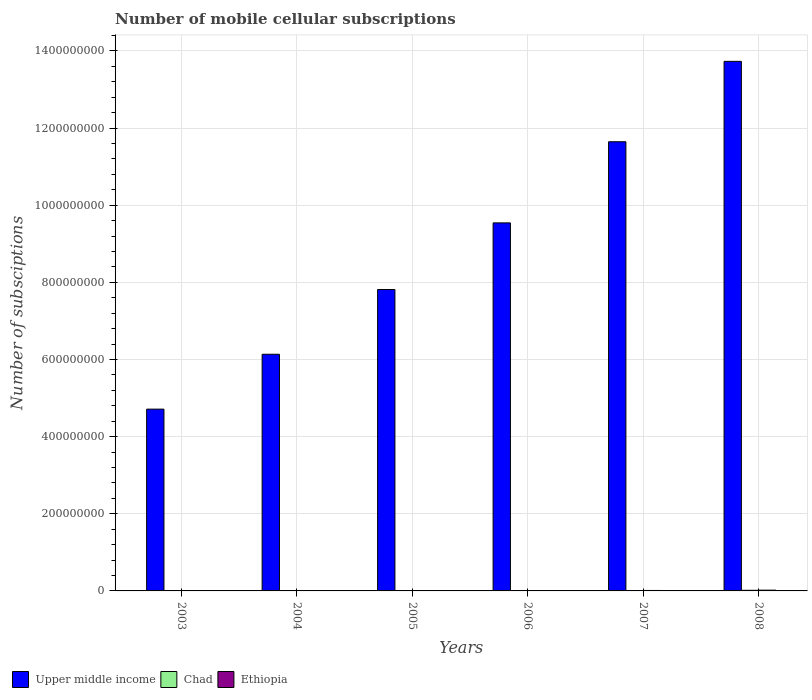How many bars are there on the 6th tick from the left?
Your answer should be very brief. 3. What is the label of the 6th group of bars from the left?
Offer a very short reply. 2008. What is the number of mobile cellular subscriptions in Ethiopia in 2008?
Offer a very short reply. 1.95e+06. Across all years, what is the maximum number of mobile cellular subscriptions in Ethiopia?
Make the answer very short. 1.95e+06. Across all years, what is the minimum number of mobile cellular subscriptions in Ethiopia?
Give a very brief answer. 5.13e+04. In which year was the number of mobile cellular subscriptions in Ethiopia maximum?
Offer a terse response. 2008. What is the total number of mobile cellular subscriptions in Ethiopia in the graph?
Give a very brief answer. 4.65e+06. What is the difference between the number of mobile cellular subscriptions in Upper middle income in 2003 and that in 2008?
Your answer should be compact. -9.02e+08. What is the difference between the number of mobile cellular subscriptions in Ethiopia in 2003 and the number of mobile cellular subscriptions in Upper middle income in 2006?
Your response must be concise. -9.54e+08. What is the average number of mobile cellular subscriptions in Ethiopia per year?
Give a very brief answer. 7.75e+05. In the year 2003, what is the difference between the number of mobile cellular subscriptions in Ethiopia and number of mobile cellular subscriptions in Chad?
Offer a very short reply. -1.37e+04. What is the ratio of the number of mobile cellular subscriptions in Ethiopia in 2006 to that in 2007?
Offer a very short reply. 0.72. What is the difference between the highest and the second highest number of mobile cellular subscriptions in Chad?
Provide a short and direct response. 6.82e+05. What is the difference between the highest and the lowest number of mobile cellular subscriptions in Ethiopia?
Ensure brevity in your answer.  1.90e+06. Is the sum of the number of mobile cellular subscriptions in Upper middle income in 2004 and 2005 greater than the maximum number of mobile cellular subscriptions in Chad across all years?
Offer a terse response. Yes. What does the 3rd bar from the left in 2006 represents?
Your answer should be very brief. Ethiopia. What does the 1st bar from the right in 2004 represents?
Keep it short and to the point. Ethiopia. Are all the bars in the graph horizontal?
Provide a short and direct response. No. What is the difference between two consecutive major ticks on the Y-axis?
Ensure brevity in your answer.  2.00e+08. How many legend labels are there?
Provide a short and direct response. 3. What is the title of the graph?
Provide a succinct answer. Number of mobile cellular subscriptions. Does "France" appear as one of the legend labels in the graph?
Ensure brevity in your answer.  No. What is the label or title of the Y-axis?
Your answer should be very brief. Number of subsciptions. What is the Number of subsciptions of Upper middle income in 2003?
Your answer should be very brief. 4.71e+08. What is the Number of subsciptions of Chad in 2003?
Offer a very short reply. 6.50e+04. What is the Number of subsciptions in Ethiopia in 2003?
Your response must be concise. 5.13e+04. What is the Number of subsciptions in Upper middle income in 2004?
Provide a succinct answer. 6.14e+08. What is the Number of subsciptions in Chad in 2004?
Make the answer very short. 1.23e+05. What is the Number of subsciptions in Ethiopia in 2004?
Provide a short and direct response. 1.56e+05. What is the Number of subsciptions of Upper middle income in 2005?
Offer a very short reply. 7.81e+08. What is the Number of subsciptions of Ethiopia in 2005?
Offer a very short reply. 4.11e+05. What is the Number of subsciptions of Upper middle income in 2006?
Your answer should be compact. 9.54e+08. What is the Number of subsciptions of Chad in 2006?
Provide a succinct answer. 4.66e+05. What is the Number of subsciptions of Ethiopia in 2006?
Ensure brevity in your answer.  8.67e+05. What is the Number of subsciptions of Upper middle income in 2007?
Your answer should be very brief. 1.16e+09. What is the Number of subsciptions in Chad in 2007?
Your answer should be compact. 9.18e+05. What is the Number of subsciptions of Ethiopia in 2007?
Keep it short and to the point. 1.21e+06. What is the Number of subsciptions in Upper middle income in 2008?
Ensure brevity in your answer.  1.37e+09. What is the Number of subsciptions of Chad in 2008?
Give a very brief answer. 1.60e+06. What is the Number of subsciptions of Ethiopia in 2008?
Offer a very short reply. 1.95e+06. Across all years, what is the maximum Number of subsciptions in Upper middle income?
Ensure brevity in your answer.  1.37e+09. Across all years, what is the maximum Number of subsciptions of Chad?
Ensure brevity in your answer.  1.60e+06. Across all years, what is the maximum Number of subsciptions of Ethiopia?
Keep it short and to the point. 1.95e+06. Across all years, what is the minimum Number of subsciptions of Upper middle income?
Offer a very short reply. 4.71e+08. Across all years, what is the minimum Number of subsciptions in Chad?
Provide a succinct answer. 6.50e+04. Across all years, what is the minimum Number of subsciptions of Ethiopia?
Your answer should be very brief. 5.13e+04. What is the total Number of subsciptions of Upper middle income in the graph?
Your answer should be compact. 5.36e+09. What is the total Number of subsciptions in Chad in the graph?
Offer a terse response. 3.38e+06. What is the total Number of subsciptions of Ethiopia in the graph?
Ensure brevity in your answer.  4.65e+06. What is the difference between the Number of subsciptions in Upper middle income in 2003 and that in 2004?
Keep it short and to the point. -1.42e+08. What is the difference between the Number of subsciptions of Chad in 2003 and that in 2004?
Offer a terse response. -5.80e+04. What is the difference between the Number of subsciptions in Ethiopia in 2003 and that in 2004?
Ensure brevity in your answer.  -1.04e+05. What is the difference between the Number of subsciptions of Upper middle income in 2003 and that in 2005?
Your answer should be very brief. -3.10e+08. What is the difference between the Number of subsciptions of Chad in 2003 and that in 2005?
Provide a short and direct response. -1.45e+05. What is the difference between the Number of subsciptions in Ethiopia in 2003 and that in 2005?
Keep it short and to the point. -3.59e+05. What is the difference between the Number of subsciptions of Upper middle income in 2003 and that in 2006?
Make the answer very short. -4.83e+08. What is the difference between the Number of subsciptions of Chad in 2003 and that in 2006?
Provide a succinct answer. -4.01e+05. What is the difference between the Number of subsciptions of Ethiopia in 2003 and that in 2006?
Provide a succinct answer. -8.15e+05. What is the difference between the Number of subsciptions of Upper middle income in 2003 and that in 2007?
Provide a short and direct response. -6.93e+08. What is the difference between the Number of subsciptions in Chad in 2003 and that in 2007?
Your response must be concise. -8.53e+05. What is the difference between the Number of subsciptions in Ethiopia in 2003 and that in 2007?
Your answer should be compact. -1.16e+06. What is the difference between the Number of subsciptions of Upper middle income in 2003 and that in 2008?
Your answer should be compact. -9.02e+08. What is the difference between the Number of subsciptions in Chad in 2003 and that in 2008?
Your response must be concise. -1.54e+06. What is the difference between the Number of subsciptions of Ethiopia in 2003 and that in 2008?
Offer a terse response. -1.90e+06. What is the difference between the Number of subsciptions of Upper middle income in 2004 and that in 2005?
Make the answer very short. -1.68e+08. What is the difference between the Number of subsciptions of Chad in 2004 and that in 2005?
Your answer should be very brief. -8.70e+04. What is the difference between the Number of subsciptions of Ethiopia in 2004 and that in 2005?
Your response must be concise. -2.55e+05. What is the difference between the Number of subsciptions of Upper middle income in 2004 and that in 2006?
Your response must be concise. -3.41e+08. What is the difference between the Number of subsciptions in Chad in 2004 and that in 2006?
Offer a very short reply. -3.43e+05. What is the difference between the Number of subsciptions of Ethiopia in 2004 and that in 2006?
Your answer should be very brief. -7.11e+05. What is the difference between the Number of subsciptions in Upper middle income in 2004 and that in 2007?
Provide a succinct answer. -5.51e+08. What is the difference between the Number of subsciptions in Chad in 2004 and that in 2007?
Make the answer very short. -7.95e+05. What is the difference between the Number of subsciptions of Ethiopia in 2004 and that in 2007?
Make the answer very short. -1.05e+06. What is the difference between the Number of subsciptions of Upper middle income in 2004 and that in 2008?
Give a very brief answer. -7.59e+08. What is the difference between the Number of subsciptions in Chad in 2004 and that in 2008?
Give a very brief answer. -1.48e+06. What is the difference between the Number of subsciptions of Ethiopia in 2004 and that in 2008?
Ensure brevity in your answer.  -1.80e+06. What is the difference between the Number of subsciptions in Upper middle income in 2005 and that in 2006?
Your response must be concise. -1.73e+08. What is the difference between the Number of subsciptions of Chad in 2005 and that in 2006?
Your response must be concise. -2.56e+05. What is the difference between the Number of subsciptions of Ethiopia in 2005 and that in 2006?
Offer a terse response. -4.56e+05. What is the difference between the Number of subsciptions of Upper middle income in 2005 and that in 2007?
Offer a terse response. -3.83e+08. What is the difference between the Number of subsciptions of Chad in 2005 and that in 2007?
Ensure brevity in your answer.  -7.08e+05. What is the difference between the Number of subsciptions of Ethiopia in 2005 and that in 2007?
Your response must be concise. -7.98e+05. What is the difference between the Number of subsciptions of Upper middle income in 2005 and that in 2008?
Keep it short and to the point. -5.92e+08. What is the difference between the Number of subsciptions of Chad in 2005 and that in 2008?
Your response must be concise. -1.39e+06. What is the difference between the Number of subsciptions of Ethiopia in 2005 and that in 2008?
Offer a very short reply. -1.54e+06. What is the difference between the Number of subsciptions of Upper middle income in 2006 and that in 2007?
Provide a short and direct response. -2.10e+08. What is the difference between the Number of subsciptions of Chad in 2006 and that in 2007?
Offer a terse response. -4.52e+05. What is the difference between the Number of subsciptions of Ethiopia in 2006 and that in 2007?
Keep it short and to the point. -3.42e+05. What is the difference between the Number of subsciptions of Upper middle income in 2006 and that in 2008?
Offer a very short reply. -4.19e+08. What is the difference between the Number of subsciptions in Chad in 2006 and that in 2008?
Provide a succinct answer. -1.13e+06. What is the difference between the Number of subsciptions of Ethiopia in 2006 and that in 2008?
Provide a succinct answer. -1.09e+06. What is the difference between the Number of subsciptions of Upper middle income in 2007 and that in 2008?
Ensure brevity in your answer.  -2.08e+08. What is the difference between the Number of subsciptions in Chad in 2007 and that in 2008?
Ensure brevity in your answer.  -6.82e+05. What is the difference between the Number of subsciptions of Ethiopia in 2007 and that in 2008?
Give a very brief answer. -7.46e+05. What is the difference between the Number of subsciptions of Upper middle income in 2003 and the Number of subsciptions of Chad in 2004?
Offer a very short reply. 4.71e+08. What is the difference between the Number of subsciptions of Upper middle income in 2003 and the Number of subsciptions of Ethiopia in 2004?
Your response must be concise. 4.71e+08. What is the difference between the Number of subsciptions of Chad in 2003 and the Number of subsciptions of Ethiopia in 2004?
Make the answer very short. -9.05e+04. What is the difference between the Number of subsciptions of Upper middle income in 2003 and the Number of subsciptions of Chad in 2005?
Your answer should be very brief. 4.71e+08. What is the difference between the Number of subsciptions in Upper middle income in 2003 and the Number of subsciptions in Ethiopia in 2005?
Your response must be concise. 4.71e+08. What is the difference between the Number of subsciptions of Chad in 2003 and the Number of subsciptions of Ethiopia in 2005?
Ensure brevity in your answer.  -3.46e+05. What is the difference between the Number of subsciptions in Upper middle income in 2003 and the Number of subsciptions in Chad in 2006?
Ensure brevity in your answer.  4.71e+08. What is the difference between the Number of subsciptions of Upper middle income in 2003 and the Number of subsciptions of Ethiopia in 2006?
Give a very brief answer. 4.70e+08. What is the difference between the Number of subsciptions in Chad in 2003 and the Number of subsciptions in Ethiopia in 2006?
Your answer should be very brief. -8.02e+05. What is the difference between the Number of subsciptions in Upper middle income in 2003 and the Number of subsciptions in Chad in 2007?
Offer a terse response. 4.70e+08. What is the difference between the Number of subsciptions of Upper middle income in 2003 and the Number of subsciptions of Ethiopia in 2007?
Your answer should be very brief. 4.70e+08. What is the difference between the Number of subsciptions in Chad in 2003 and the Number of subsciptions in Ethiopia in 2007?
Offer a very short reply. -1.14e+06. What is the difference between the Number of subsciptions in Upper middle income in 2003 and the Number of subsciptions in Chad in 2008?
Provide a succinct answer. 4.70e+08. What is the difference between the Number of subsciptions of Upper middle income in 2003 and the Number of subsciptions of Ethiopia in 2008?
Keep it short and to the point. 4.69e+08. What is the difference between the Number of subsciptions in Chad in 2003 and the Number of subsciptions in Ethiopia in 2008?
Ensure brevity in your answer.  -1.89e+06. What is the difference between the Number of subsciptions in Upper middle income in 2004 and the Number of subsciptions in Chad in 2005?
Offer a very short reply. 6.13e+08. What is the difference between the Number of subsciptions of Upper middle income in 2004 and the Number of subsciptions of Ethiopia in 2005?
Make the answer very short. 6.13e+08. What is the difference between the Number of subsciptions of Chad in 2004 and the Number of subsciptions of Ethiopia in 2005?
Ensure brevity in your answer.  -2.88e+05. What is the difference between the Number of subsciptions of Upper middle income in 2004 and the Number of subsciptions of Chad in 2006?
Your response must be concise. 6.13e+08. What is the difference between the Number of subsciptions in Upper middle income in 2004 and the Number of subsciptions in Ethiopia in 2006?
Your response must be concise. 6.13e+08. What is the difference between the Number of subsciptions in Chad in 2004 and the Number of subsciptions in Ethiopia in 2006?
Your answer should be very brief. -7.44e+05. What is the difference between the Number of subsciptions in Upper middle income in 2004 and the Number of subsciptions in Chad in 2007?
Provide a succinct answer. 6.13e+08. What is the difference between the Number of subsciptions of Upper middle income in 2004 and the Number of subsciptions of Ethiopia in 2007?
Your response must be concise. 6.12e+08. What is the difference between the Number of subsciptions of Chad in 2004 and the Number of subsciptions of Ethiopia in 2007?
Offer a terse response. -1.09e+06. What is the difference between the Number of subsciptions of Upper middle income in 2004 and the Number of subsciptions of Chad in 2008?
Ensure brevity in your answer.  6.12e+08. What is the difference between the Number of subsciptions of Upper middle income in 2004 and the Number of subsciptions of Ethiopia in 2008?
Your answer should be very brief. 6.12e+08. What is the difference between the Number of subsciptions in Chad in 2004 and the Number of subsciptions in Ethiopia in 2008?
Offer a terse response. -1.83e+06. What is the difference between the Number of subsciptions of Upper middle income in 2005 and the Number of subsciptions of Chad in 2006?
Provide a short and direct response. 7.81e+08. What is the difference between the Number of subsciptions of Upper middle income in 2005 and the Number of subsciptions of Ethiopia in 2006?
Keep it short and to the point. 7.81e+08. What is the difference between the Number of subsciptions of Chad in 2005 and the Number of subsciptions of Ethiopia in 2006?
Your response must be concise. -6.57e+05. What is the difference between the Number of subsciptions in Upper middle income in 2005 and the Number of subsciptions in Chad in 2007?
Make the answer very short. 7.80e+08. What is the difference between the Number of subsciptions of Upper middle income in 2005 and the Number of subsciptions of Ethiopia in 2007?
Your answer should be very brief. 7.80e+08. What is the difference between the Number of subsciptions in Chad in 2005 and the Number of subsciptions in Ethiopia in 2007?
Provide a succinct answer. -9.98e+05. What is the difference between the Number of subsciptions in Upper middle income in 2005 and the Number of subsciptions in Chad in 2008?
Offer a terse response. 7.80e+08. What is the difference between the Number of subsciptions of Upper middle income in 2005 and the Number of subsciptions of Ethiopia in 2008?
Provide a succinct answer. 7.79e+08. What is the difference between the Number of subsciptions in Chad in 2005 and the Number of subsciptions in Ethiopia in 2008?
Offer a very short reply. -1.74e+06. What is the difference between the Number of subsciptions of Upper middle income in 2006 and the Number of subsciptions of Chad in 2007?
Your answer should be compact. 9.53e+08. What is the difference between the Number of subsciptions of Upper middle income in 2006 and the Number of subsciptions of Ethiopia in 2007?
Your response must be concise. 9.53e+08. What is the difference between the Number of subsciptions in Chad in 2006 and the Number of subsciptions in Ethiopia in 2007?
Your answer should be very brief. -7.42e+05. What is the difference between the Number of subsciptions of Upper middle income in 2006 and the Number of subsciptions of Chad in 2008?
Offer a very short reply. 9.53e+08. What is the difference between the Number of subsciptions in Upper middle income in 2006 and the Number of subsciptions in Ethiopia in 2008?
Offer a very short reply. 9.52e+08. What is the difference between the Number of subsciptions of Chad in 2006 and the Number of subsciptions of Ethiopia in 2008?
Provide a short and direct response. -1.49e+06. What is the difference between the Number of subsciptions in Upper middle income in 2007 and the Number of subsciptions in Chad in 2008?
Make the answer very short. 1.16e+09. What is the difference between the Number of subsciptions of Upper middle income in 2007 and the Number of subsciptions of Ethiopia in 2008?
Provide a short and direct response. 1.16e+09. What is the difference between the Number of subsciptions in Chad in 2007 and the Number of subsciptions in Ethiopia in 2008?
Your response must be concise. -1.04e+06. What is the average Number of subsciptions in Upper middle income per year?
Your answer should be very brief. 8.93e+08. What is the average Number of subsciptions of Chad per year?
Your response must be concise. 5.64e+05. What is the average Number of subsciptions of Ethiopia per year?
Ensure brevity in your answer.  7.75e+05. In the year 2003, what is the difference between the Number of subsciptions of Upper middle income and Number of subsciptions of Chad?
Your answer should be compact. 4.71e+08. In the year 2003, what is the difference between the Number of subsciptions of Upper middle income and Number of subsciptions of Ethiopia?
Provide a short and direct response. 4.71e+08. In the year 2003, what is the difference between the Number of subsciptions in Chad and Number of subsciptions in Ethiopia?
Ensure brevity in your answer.  1.37e+04. In the year 2004, what is the difference between the Number of subsciptions in Upper middle income and Number of subsciptions in Chad?
Provide a succinct answer. 6.13e+08. In the year 2004, what is the difference between the Number of subsciptions in Upper middle income and Number of subsciptions in Ethiopia?
Offer a very short reply. 6.13e+08. In the year 2004, what is the difference between the Number of subsciptions of Chad and Number of subsciptions of Ethiopia?
Keep it short and to the point. -3.25e+04. In the year 2005, what is the difference between the Number of subsciptions in Upper middle income and Number of subsciptions in Chad?
Provide a succinct answer. 7.81e+08. In the year 2005, what is the difference between the Number of subsciptions of Upper middle income and Number of subsciptions of Ethiopia?
Your answer should be compact. 7.81e+08. In the year 2005, what is the difference between the Number of subsciptions in Chad and Number of subsciptions in Ethiopia?
Your response must be concise. -2.01e+05. In the year 2006, what is the difference between the Number of subsciptions in Upper middle income and Number of subsciptions in Chad?
Provide a short and direct response. 9.54e+08. In the year 2006, what is the difference between the Number of subsciptions of Upper middle income and Number of subsciptions of Ethiopia?
Your answer should be very brief. 9.53e+08. In the year 2006, what is the difference between the Number of subsciptions of Chad and Number of subsciptions of Ethiopia?
Ensure brevity in your answer.  -4.01e+05. In the year 2007, what is the difference between the Number of subsciptions of Upper middle income and Number of subsciptions of Chad?
Keep it short and to the point. 1.16e+09. In the year 2007, what is the difference between the Number of subsciptions in Upper middle income and Number of subsciptions in Ethiopia?
Your answer should be very brief. 1.16e+09. In the year 2007, what is the difference between the Number of subsciptions of Chad and Number of subsciptions of Ethiopia?
Keep it short and to the point. -2.90e+05. In the year 2008, what is the difference between the Number of subsciptions in Upper middle income and Number of subsciptions in Chad?
Your answer should be compact. 1.37e+09. In the year 2008, what is the difference between the Number of subsciptions in Upper middle income and Number of subsciptions in Ethiopia?
Ensure brevity in your answer.  1.37e+09. In the year 2008, what is the difference between the Number of subsciptions in Chad and Number of subsciptions in Ethiopia?
Offer a terse response. -3.55e+05. What is the ratio of the Number of subsciptions of Upper middle income in 2003 to that in 2004?
Your response must be concise. 0.77. What is the ratio of the Number of subsciptions in Chad in 2003 to that in 2004?
Offer a terse response. 0.53. What is the ratio of the Number of subsciptions in Ethiopia in 2003 to that in 2004?
Offer a terse response. 0.33. What is the ratio of the Number of subsciptions of Upper middle income in 2003 to that in 2005?
Your response must be concise. 0.6. What is the ratio of the Number of subsciptions in Chad in 2003 to that in 2005?
Offer a terse response. 0.31. What is the ratio of the Number of subsciptions in Ethiopia in 2003 to that in 2005?
Give a very brief answer. 0.12. What is the ratio of the Number of subsciptions in Upper middle income in 2003 to that in 2006?
Give a very brief answer. 0.49. What is the ratio of the Number of subsciptions in Chad in 2003 to that in 2006?
Keep it short and to the point. 0.14. What is the ratio of the Number of subsciptions in Ethiopia in 2003 to that in 2006?
Keep it short and to the point. 0.06. What is the ratio of the Number of subsciptions of Upper middle income in 2003 to that in 2007?
Provide a short and direct response. 0.4. What is the ratio of the Number of subsciptions of Chad in 2003 to that in 2007?
Make the answer very short. 0.07. What is the ratio of the Number of subsciptions of Ethiopia in 2003 to that in 2007?
Offer a terse response. 0.04. What is the ratio of the Number of subsciptions of Upper middle income in 2003 to that in 2008?
Your response must be concise. 0.34. What is the ratio of the Number of subsciptions in Chad in 2003 to that in 2008?
Your response must be concise. 0.04. What is the ratio of the Number of subsciptions in Ethiopia in 2003 to that in 2008?
Provide a succinct answer. 0.03. What is the ratio of the Number of subsciptions in Upper middle income in 2004 to that in 2005?
Keep it short and to the point. 0.79. What is the ratio of the Number of subsciptions of Chad in 2004 to that in 2005?
Ensure brevity in your answer.  0.59. What is the ratio of the Number of subsciptions in Ethiopia in 2004 to that in 2005?
Your answer should be compact. 0.38. What is the ratio of the Number of subsciptions in Upper middle income in 2004 to that in 2006?
Your answer should be compact. 0.64. What is the ratio of the Number of subsciptions in Chad in 2004 to that in 2006?
Your answer should be very brief. 0.26. What is the ratio of the Number of subsciptions of Ethiopia in 2004 to that in 2006?
Provide a succinct answer. 0.18. What is the ratio of the Number of subsciptions of Upper middle income in 2004 to that in 2007?
Offer a very short reply. 0.53. What is the ratio of the Number of subsciptions of Chad in 2004 to that in 2007?
Make the answer very short. 0.13. What is the ratio of the Number of subsciptions of Ethiopia in 2004 to that in 2007?
Keep it short and to the point. 0.13. What is the ratio of the Number of subsciptions of Upper middle income in 2004 to that in 2008?
Ensure brevity in your answer.  0.45. What is the ratio of the Number of subsciptions of Chad in 2004 to that in 2008?
Give a very brief answer. 0.08. What is the ratio of the Number of subsciptions of Ethiopia in 2004 to that in 2008?
Offer a terse response. 0.08. What is the ratio of the Number of subsciptions in Upper middle income in 2005 to that in 2006?
Provide a short and direct response. 0.82. What is the ratio of the Number of subsciptions of Chad in 2005 to that in 2006?
Offer a terse response. 0.45. What is the ratio of the Number of subsciptions in Ethiopia in 2005 to that in 2006?
Your answer should be compact. 0.47. What is the ratio of the Number of subsciptions in Upper middle income in 2005 to that in 2007?
Keep it short and to the point. 0.67. What is the ratio of the Number of subsciptions of Chad in 2005 to that in 2007?
Ensure brevity in your answer.  0.23. What is the ratio of the Number of subsciptions of Ethiopia in 2005 to that in 2007?
Your response must be concise. 0.34. What is the ratio of the Number of subsciptions of Upper middle income in 2005 to that in 2008?
Your response must be concise. 0.57. What is the ratio of the Number of subsciptions in Chad in 2005 to that in 2008?
Offer a very short reply. 0.13. What is the ratio of the Number of subsciptions in Ethiopia in 2005 to that in 2008?
Provide a succinct answer. 0.21. What is the ratio of the Number of subsciptions of Upper middle income in 2006 to that in 2007?
Provide a short and direct response. 0.82. What is the ratio of the Number of subsciptions of Chad in 2006 to that in 2007?
Provide a short and direct response. 0.51. What is the ratio of the Number of subsciptions of Ethiopia in 2006 to that in 2007?
Your response must be concise. 0.72. What is the ratio of the Number of subsciptions of Upper middle income in 2006 to that in 2008?
Provide a short and direct response. 0.69. What is the ratio of the Number of subsciptions of Chad in 2006 to that in 2008?
Your answer should be very brief. 0.29. What is the ratio of the Number of subsciptions in Ethiopia in 2006 to that in 2008?
Your answer should be very brief. 0.44. What is the ratio of the Number of subsciptions of Upper middle income in 2007 to that in 2008?
Your answer should be compact. 0.85. What is the ratio of the Number of subsciptions of Chad in 2007 to that in 2008?
Ensure brevity in your answer.  0.57. What is the ratio of the Number of subsciptions of Ethiopia in 2007 to that in 2008?
Offer a terse response. 0.62. What is the difference between the highest and the second highest Number of subsciptions of Upper middle income?
Make the answer very short. 2.08e+08. What is the difference between the highest and the second highest Number of subsciptions in Chad?
Provide a succinct answer. 6.82e+05. What is the difference between the highest and the second highest Number of subsciptions of Ethiopia?
Your answer should be compact. 7.46e+05. What is the difference between the highest and the lowest Number of subsciptions in Upper middle income?
Provide a short and direct response. 9.02e+08. What is the difference between the highest and the lowest Number of subsciptions in Chad?
Keep it short and to the point. 1.54e+06. What is the difference between the highest and the lowest Number of subsciptions in Ethiopia?
Offer a very short reply. 1.90e+06. 